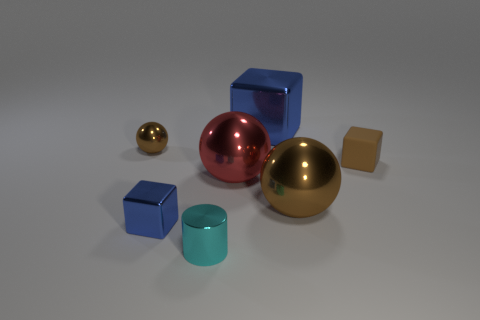Subtract all gray cubes. How many brown spheres are left? 2 Subtract all large metal spheres. How many spheres are left? 1 Add 1 tiny matte cubes. How many objects exist? 8 Subtract all spheres. How many objects are left? 4 Add 2 tiny cyan cylinders. How many tiny cyan cylinders exist? 3 Subtract 1 brown blocks. How many objects are left? 6 Subtract all metal objects. Subtract all brown matte blocks. How many objects are left? 0 Add 4 brown shiny objects. How many brown shiny objects are left? 6 